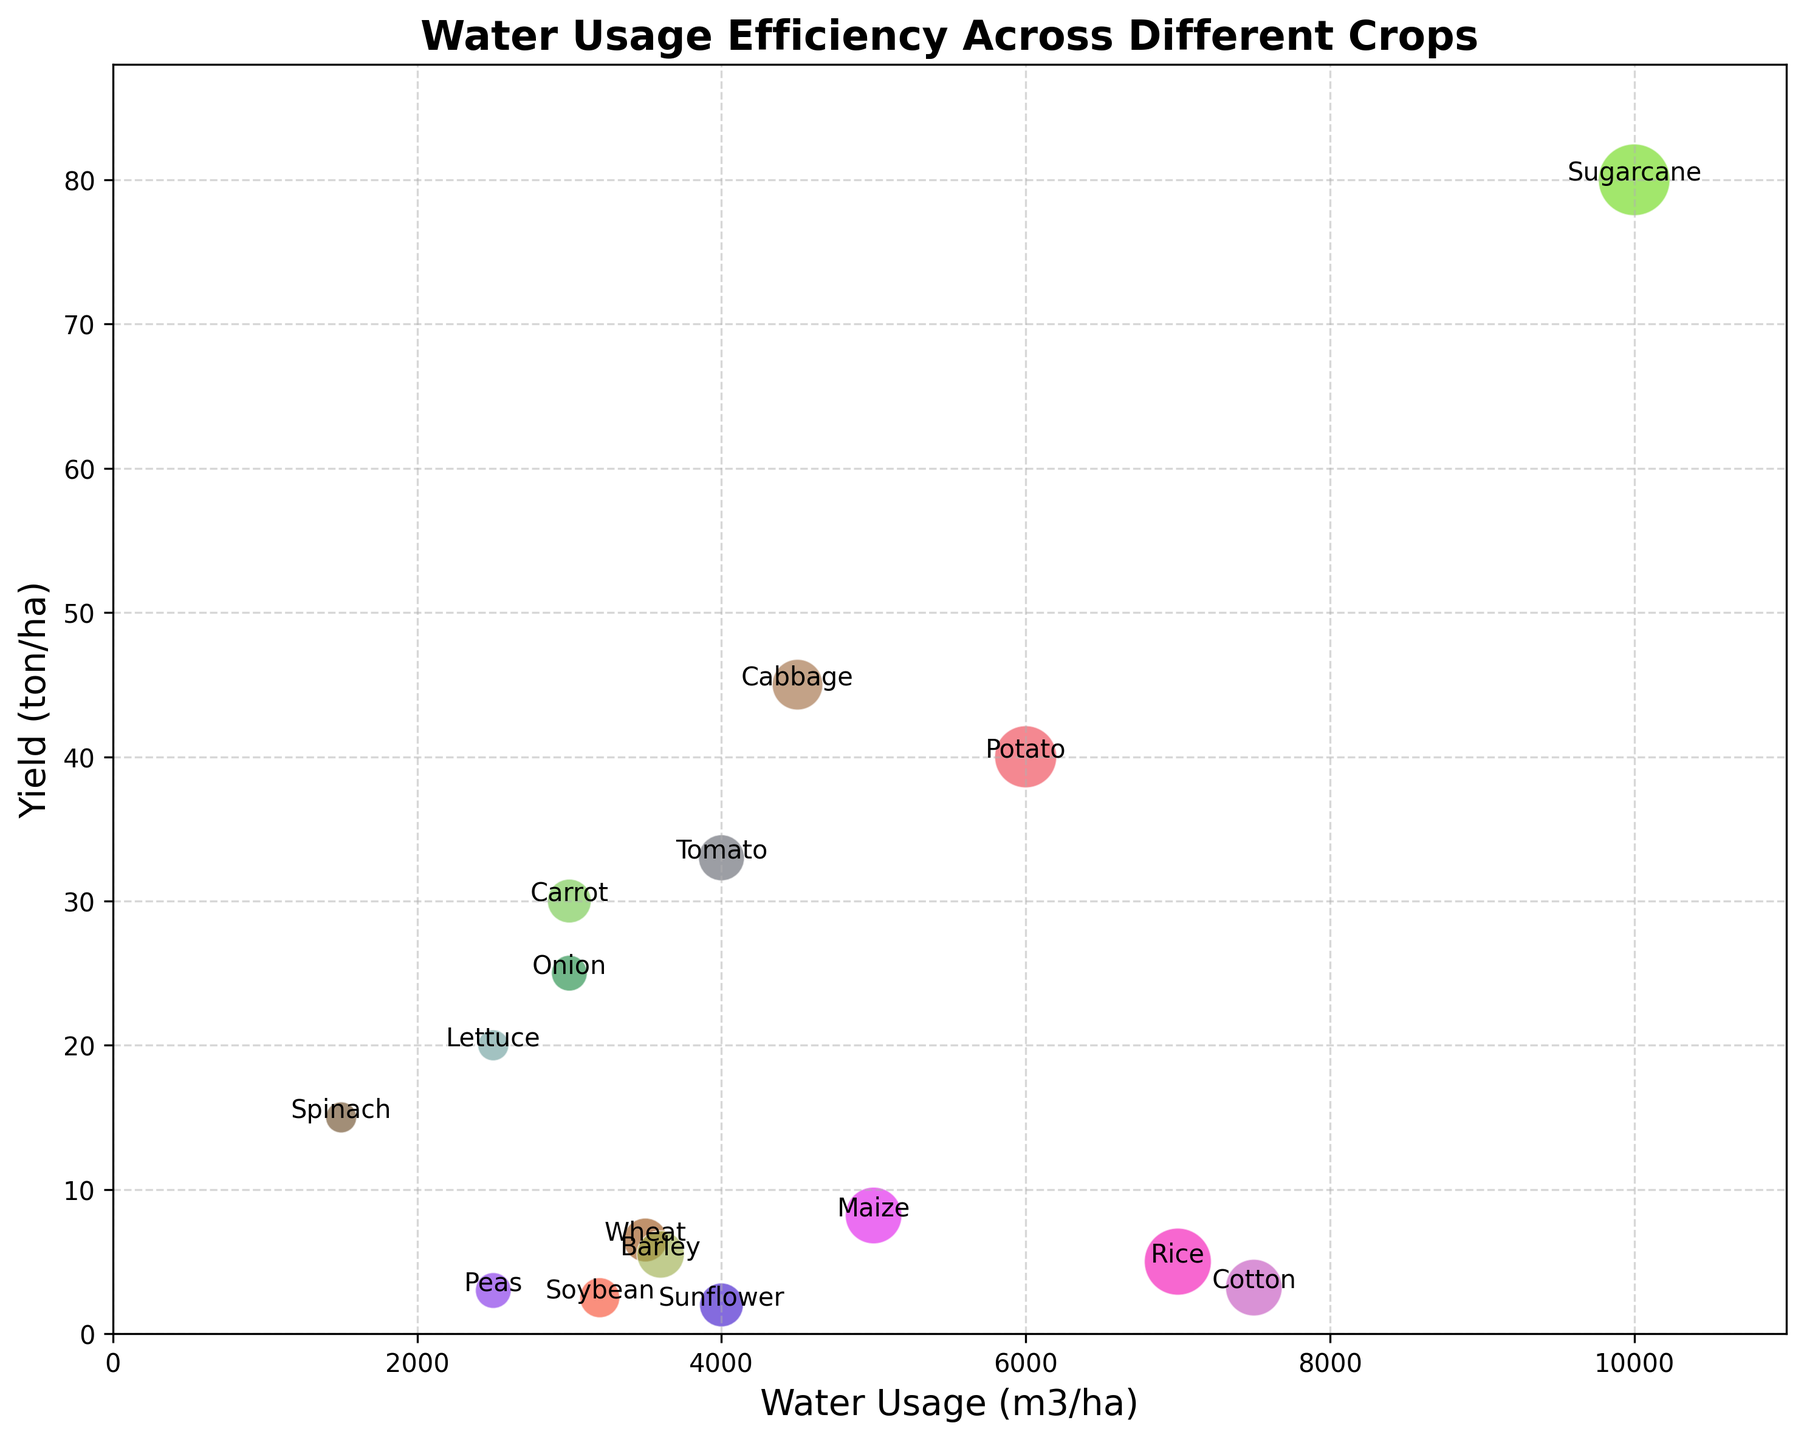What crop has the highest water usage? To determine the crop with the highest water usage, we need to look at the x-axis values. The crop with the highest x-value corresponds to the highest water usage. From the data, it is clear that Sugarcane has the highest water usage, at 10,000 m3/ha.
Answer: Sugarcane Which crop has the largest yield per hectare? We need to identify the crop with the highest y-axis value, as the y-axis represents the yield per hectare. From the chart, Sugarcane has the largest yield per hectare at 80 ton/ha.
Answer: Sugarcane Between Potato and Tomato, which has a higher water usage efficiency? The water usage efficiency is calculated as yield divided by water usage. From the data, Potato has an efficiency of 0.00667 ton/m3 and Tomato has an efficiency of 0.00825 ton/m3. Comparing these values, Tomato has a higher water usage efficiency.
Answer: Tomato Which crop has the smallest bubble size? Bubble size correlates with the numerical values given in the BubbleSize column. The smallest bubble size in the data is 15, which corresponds to Spinach and Lettuce.
Answer: Spinach, Lettuce Arrange Wheat, Maize, and Rice in descending order of their waste usage. We must look at the x-axis values for Wheat, Maize, and Rice. Wheat has 3500 m3/ha, Maize has 5000 m3/ha, and Rice has 7000 m3/ha. Arranging in descending order: Rice, Maize, Wheat.
Answer: Rice, Maize, Wheat What crop with a water usage below 5000 m3/ha has the highest yield? We focus on crops with water usage less than 5000 m3/ha, then look for the highest y-axis value among them. From the chart, crops such as Onion (25 ton/ha), Spinach (15 ton/ha), and Lettuce (20 ton/ha) need to be checked. The crop with the highest yield is Onion at 25 ton/ha.
Answer: Onion Which crop has both water usage and yield above 4000 m3/ha and 30 ton/ha respectively? From the datasets, we need to check for conditions where both water usage and yield are above the mentioned values. Carrot, Cabbage, and Sugarcane meet these criteria.
Answer: Carrot, Cabbage, Sugarcane What is the average yield of crops that use less than 3500 m3/ha of water? The crops are Peas (3 ton/ha), Lettuce (20 ton/ha), Spinach (15 ton/ha), Onion (25 ton/ha). The average yield is calculated as (3 + 20 + 15 + 25) / 4 = 15.75 ton/ha.
Answer: 15.75 Identify the crop with the lowest yield but still having a bubble size equal or more than 50. Within the dataset, we look for crops with a bubble size of 50 or above: Maize, Cotton, Potato, Sugarcane. Cotton yield is 3.2 ton/ha, the lowest yield among them.
Answer: Cotton If we increase the water usage in Rice to 8000 m3/ha, how does it compare to the bubble size of Cotton? Initially, Cotton has a water usage of 7500 m3/ha, which is slightly below the new Rice water usage. The comparison is between 8000 m3/ha for Rice and 7500 m3/ha for Cotton.
Answer: Rice uses more 